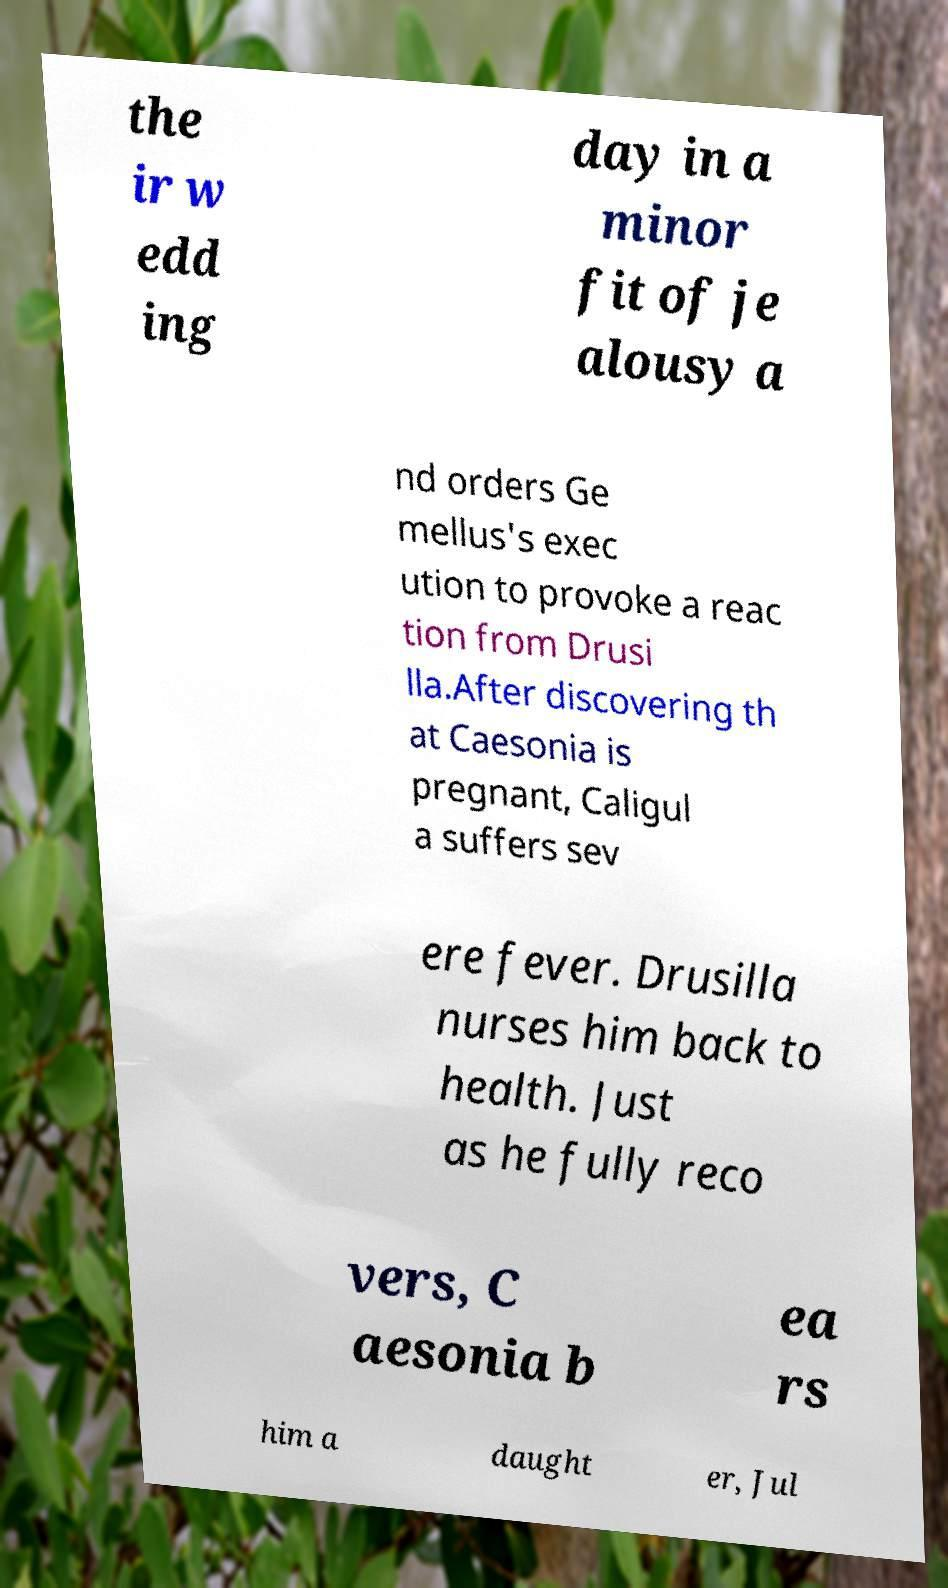Please read and relay the text visible in this image. What does it say? the ir w edd ing day in a minor fit of je alousy a nd orders Ge mellus's exec ution to provoke a reac tion from Drusi lla.After discovering th at Caesonia is pregnant, Caligul a suffers sev ere fever. Drusilla nurses him back to health. Just as he fully reco vers, C aesonia b ea rs him a daught er, Jul 